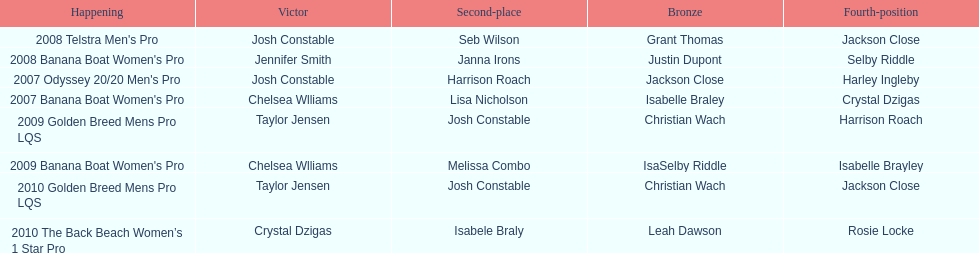Could you parse the entire table as a dict? {'header': ['Happening', 'Victor', 'Second-place', 'Bronze', 'Fourth-position'], 'rows': [["2008 Telstra Men's Pro", 'Josh Constable', 'Seb Wilson', 'Grant Thomas', 'Jackson Close'], ["2008 Banana Boat Women's Pro", 'Jennifer Smith', 'Janna Irons', 'Justin Dupont', 'Selby Riddle'], ["2007 Odyssey 20/20 Men's Pro", 'Josh Constable', 'Harrison Roach', 'Jackson Close', 'Harley Ingleby'], ["2007 Banana Boat Women's Pro", 'Chelsea Wlliams', 'Lisa Nicholson', 'Isabelle Braley', 'Crystal Dzigas'], ['2009 Golden Breed Mens Pro LQS', 'Taylor Jensen', 'Josh Constable', 'Christian Wach', 'Harrison Roach'], ["2009 Banana Boat Women's Pro", 'Chelsea Wlliams', 'Melissa Combo', 'IsaSelby Riddle', 'Isabelle Brayley'], ['2010 Golden Breed Mens Pro LQS', 'Taylor Jensen', 'Josh Constable', 'Christian Wach', 'Jackson Close'], ['2010 The Back Beach Women’s 1 Star Pro', 'Crystal Dzigas', 'Isabele Braly', 'Leah Dawson', 'Rosie Locke']]} After 2007, how many times did josh constable emerge as the winner? 1. 